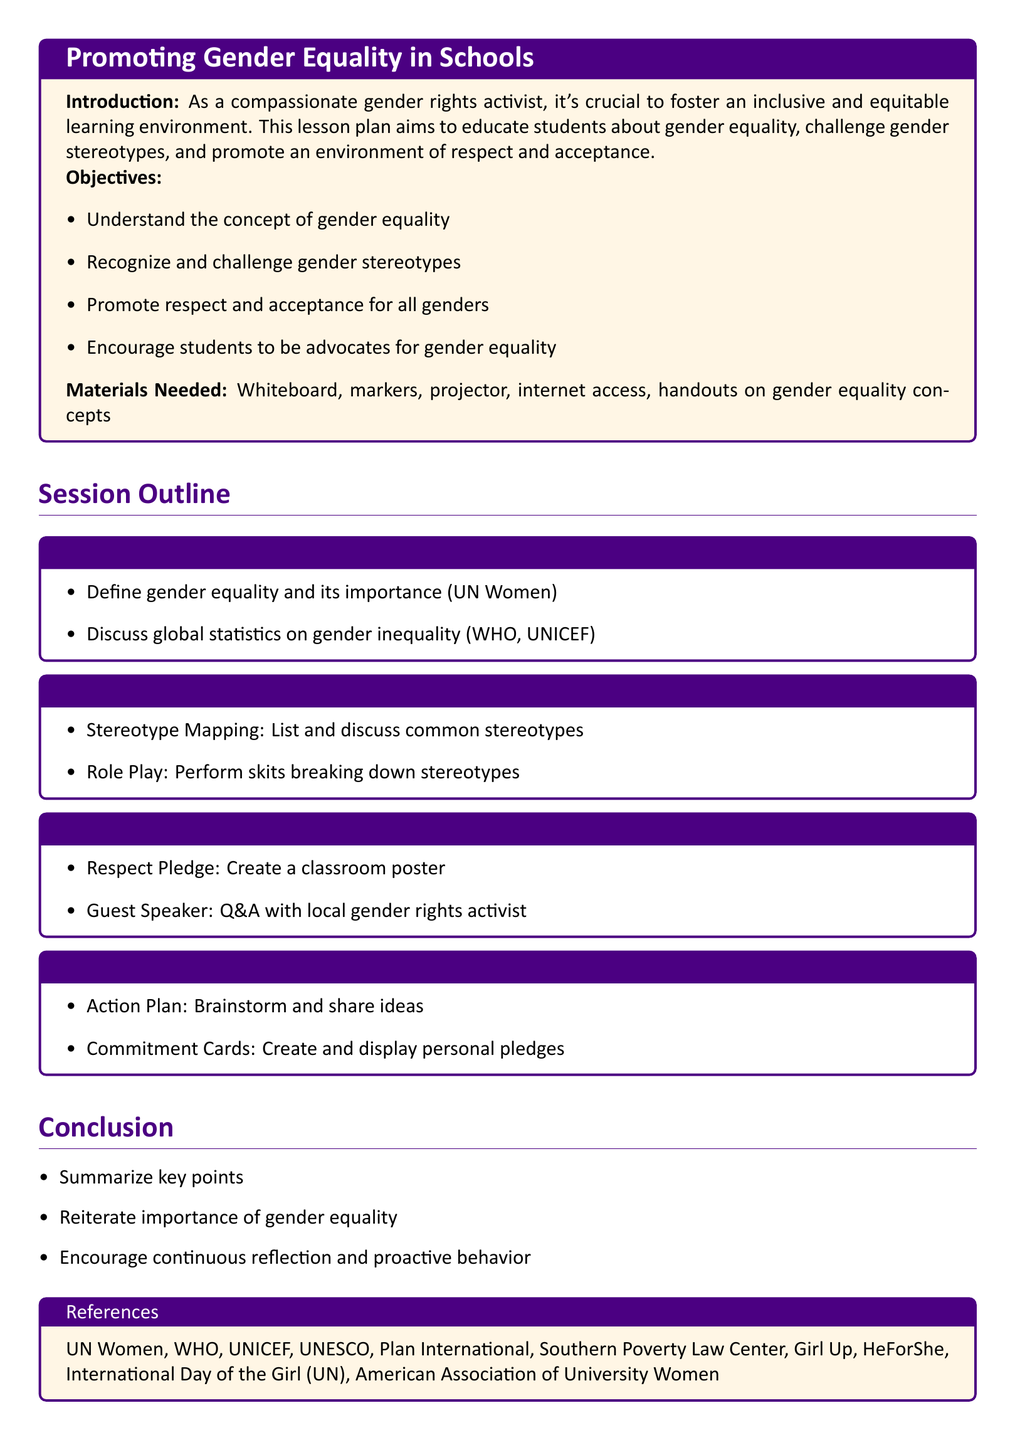What is the title of the lesson plan? The title of the lesson plan is located at the top of the document in a tcolorbox format.
Answer: Promoting Gender Equality in Schools What is the first session topic? The first session topic is outlined in a tcolorbox, specifying the focus of the introductory session.
Answer: Introduction to Gender Equality How long is the session on "Challenging Gender Stereotypes"? The duration of each session is detailed alongside the session titles, specifying the time allocated.
Answer: 20 min What is one activity included in the session on "Promoting Respect and Acceptance"? A list of activities within each session is provided, showing what students will engage in during the session.
Answer: Guest Speaker What do students create in the "Becoming Advocates" session? The session details what students will produce as part of their advocacy efforts.
Answer: Commitment Cards What is one of the objectives of the lesson plan? The objectives are clearly listed, outlining what students will be able to understand or achieve.
Answer: Understand the concept of gender equality Who are the intended references mentioned in the conclusion? A specific section lists organizations that are referenced, emphasizing their importance in gender equality advocacy.
Answer: UN Women What color is used for the headings in the document? The color scheme is defined in the document, indicating how different elements are visually represented.
Answer: maincolor 